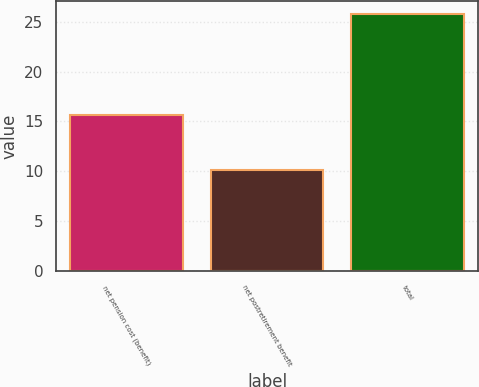<chart> <loc_0><loc_0><loc_500><loc_500><bar_chart><fcel>net pension cost (benefit)<fcel>net postretirement benefit<fcel>total<nl><fcel>15.7<fcel>10.1<fcel>25.8<nl></chart> 